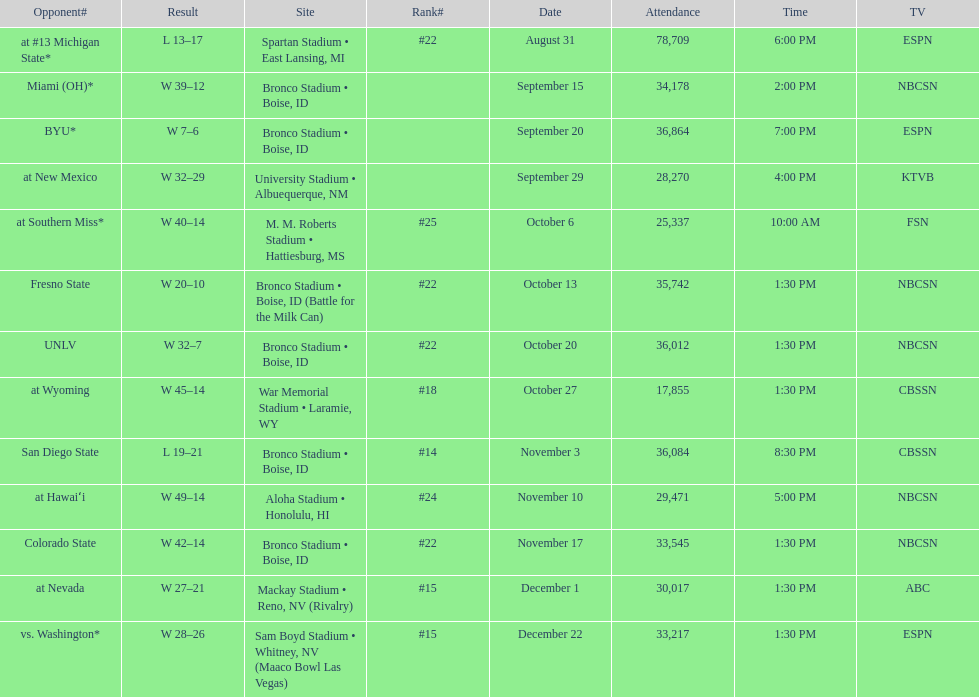What was the most consecutive wins for the team shown in the season? 7. 